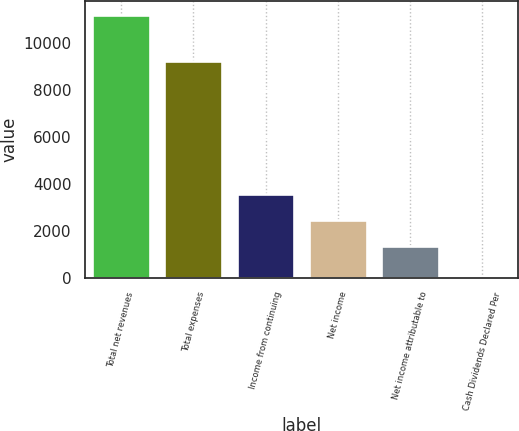Convert chart. <chart><loc_0><loc_0><loc_500><loc_500><bar_chart><fcel>Total net revenues<fcel>Total expenses<fcel>Income from continuing<fcel>Net income<fcel>Net income attributable to<fcel>Cash Dividends Declared Per<nl><fcel>11199<fcel>9229<fcel>3573.4<fcel>2453.7<fcel>1334<fcel>2.01<nl></chart> 